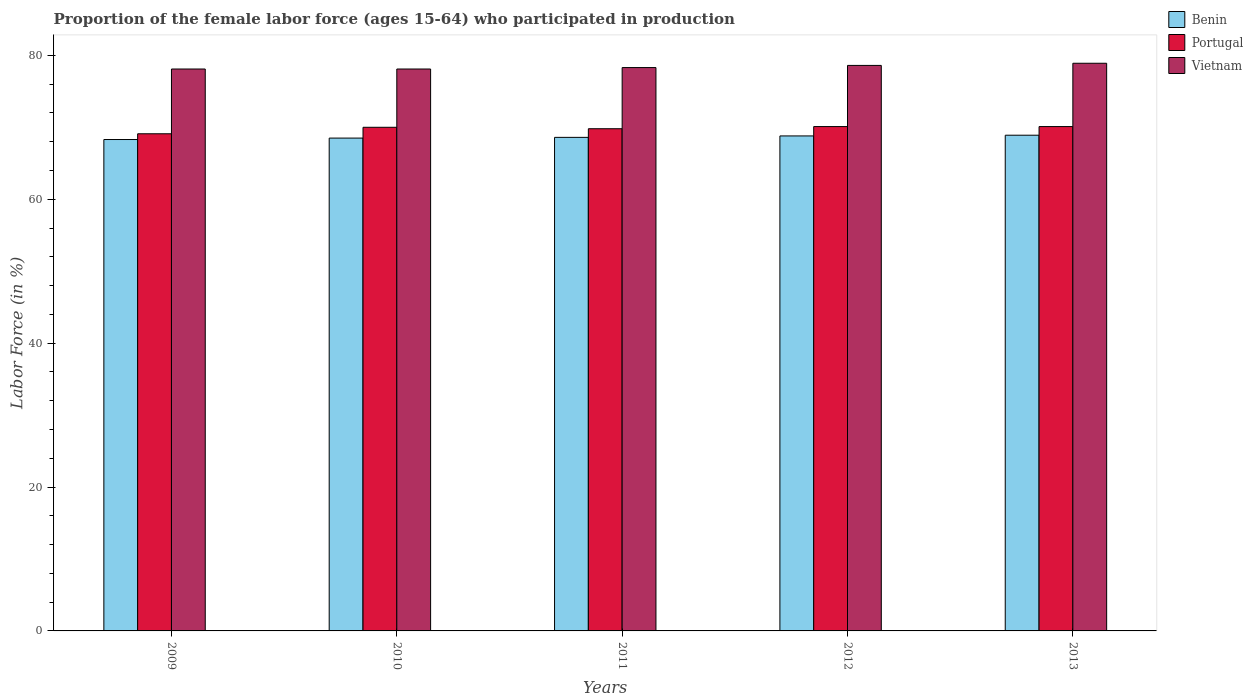Are the number of bars per tick equal to the number of legend labels?
Offer a terse response. Yes. Are the number of bars on each tick of the X-axis equal?
Keep it short and to the point. Yes. How many bars are there on the 5th tick from the left?
Offer a terse response. 3. What is the label of the 1st group of bars from the left?
Offer a very short reply. 2009. In how many cases, is the number of bars for a given year not equal to the number of legend labels?
Your response must be concise. 0. What is the proportion of the female labor force who participated in production in Benin in 2013?
Ensure brevity in your answer.  68.9. Across all years, what is the maximum proportion of the female labor force who participated in production in Vietnam?
Give a very brief answer. 78.9. Across all years, what is the minimum proportion of the female labor force who participated in production in Portugal?
Your answer should be very brief. 69.1. What is the total proportion of the female labor force who participated in production in Benin in the graph?
Your response must be concise. 343.1. What is the difference between the proportion of the female labor force who participated in production in Portugal in 2009 and that in 2013?
Your answer should be very brief. -1. What is the difference between the proportion of the female labor force who participated in production in Portugal in 2010 and the proportion of the female labor force who participated in production in Benin in 2009?
Your answer should be compact. 1.7. What is the average proportion of the female labor force who participated in production in Vietnam per year?
Your answer should be very brief. 78.4. In the year 2013, what is the difference between the proportion of the female labor force who participated in production in Portugal and proportion of the female labor force who participated in production in Benin?
Give a very brief answer. 1.2. What is the ratio of the proportion of the female labor force who participated in production in Benin in 2009 to that in 2012?
Offer a very short reply. 0.99. Is the proportion of the female labor force who participated in production in Portugal in 2010 less than that in 2013?
Make the answer very short. Yes. What is the difference between the highest and the lowest proportion of the female labor force who participated in production in Benin?
Your response must be concise. 0.6. In how many years, is the proportion of the female labor force who participated in production in Benin greater than the average proportion of the female labor force who participated in production in Benin taken over all years?
Keep it short and to the point. 2. What does the 2nd bar from the left in 2012 represents?
Offer a terse response. Portugal. What does the 1st bar from the right in 2010 represents?
Keep it short and to the point. Vietnam. Is it the case that in every year, the sum of the proportion of the female labor force who participated in production in Portugal and proportion of the female labor force who participated in production in Benin is greater than the proportion of the female labor force who participated in production in Vietnam?
Your answer should be very brief. Yes. How many bars are there?
Make the answer very short. 15. Are all the bars in the graph horizontal?
Offer a terse response. No. Does the graph contain grids?
Your answer should be very brief. No. Where does the legend appear in the graph?
Make the answer very short. Top right. What is the title of the graph?
Keep it short and to the point. Proportion of the female labor force (ages 15-64) who participated in production. What is the label or title of the X-axis?
Keep it short and to the point. Years. What is the Labor Force (in %) of Benin in 2009?
Your answer should be compact. 68.3. What is the Labor Force (in %) in Portugal in 2009?
Give a very brief answer. 69.1. What is the Labor Force (in %) in Vietnam in 2009?
Your response must be concise. 78.1. What is the Labor Force (in %) in Benin in 2010?
Give a very brief answer. 68.5. What is the Labor Force (in %) in Portugal in 2010?
Offer a very short reply. 70. What is the Labor Force (in %) in Vietnam in 2010?
Provide a short and direct response. 78.1. What is the Labor Force (in %) in Benin in 2011?
Keep it short and to the point. 68.6. What is the Labor Force (in %) of Portugal in 2011?
Provide a short and direct response. 69.8. What is the Labor Force (in %) in Vietnam in 2011?
Provide a short and direct response. 78.3. What is the Labor Force (in %) in Benin in 2012?
Provide a succinct answer. 68.8. What is the Labor Force (in %) in Portugal in 2012?
Make the answer very short. 70.1. What is the Labor Force (in %) in Vietnam in 2012?
Your answer should be compact. 78.6. What is the Labor Force (in %) of Benin in 2013?
Your response must be concise. 68.9. What is the Labor Force (in %) in Portugal in 2013?
Your response must be concise. 70.1. What is the Labor Force (in %) in Vietnam in 2013?
Ensure brevity in your answer.  78.9. Across all years, what is the maximum Labor Force (in %) in Benin?
Make the answer very short. 68.9. Across all years, what is the maximum Labor Force (in %) in Portugal?
Your answer should be very brief. 70.1. Across all years, what is the maximum Labor Force (in %) of Vietnam?
Provide a succinct answer. 78.9. Across all years, what is the minimum Labor Force (in %) in Benin?
Give a very brief answer. 68.3. Across all years, what is the minimum Labor Force (in %) of Portugal?
Offer a very short reply. 69.1. Across all years, what is the minimum Labor Force (in %) in Vietnam?
Offer a very short reply. 78.1. What is the total Labor Force (in %) in Benin in the graph?
Give a very brief answer. 343.1. What is the total Labor Force (in %) in Portugal in the graph?
Your answer should be very brief. 349.1. What is the total Labor Force (in %) of Vietnam in the graph?
Provide a short and direct response. 392. What is the difference between the Labor Force (in %) of Portugal in 2009 and that in 2010?
Keep it short and to the point. -0.9. What is the difference between the Labor Force (in %) in Portugal in 2009 and that in 2011?
Give a very brief answer. -0.7. What is the difference between the Labor Force (in %) in Vietnam in 2009 and that in 2011?
Your answer should be compact. -0.2. What is the difference between the Labor Force (in %) in Portugal in 2009 and that in 2013?
Your answer should be compact. -1. What is the difference between the Labor Force (in %) in Benin in 2010 and that in 2011?
Provide a succinct answer. -0.1. What is the difference between the Labor Force (in %) in Portugal in 2010 and that in 2011?
Make the answer very short. 0.2. What is the difference between the Labor Force (in %) in Vietnam in 2010 and that in 2011?
Make the answer very short. -0.2. What is the difference between the Labor Force (in %) in Benin in 2010 and that in 2013?
Provide a succinct answer. -0.4. What is the difference between the Labor Force (in %) in Portugal in 2010 and that in 2013?
Your answer should be compact. -0.1. What is the difference between the Labor Force (in %) in Benin in 2011 and that in 2012?
Make the answer very short. -0.2. What is the difference between the Labor Force (in %) of Portugal in 2011 and that in 2013?
Make the answer very short. -0.3. What is the difference between the Labor Force (in %) of Portugal in 2012 and that in 2013?
Give a very brief answer. 0. What is the difference between the Labor Force (in %) in Vietnam in 2012 and that in 2013?
Your answer should be compact. -0.3. What is the difference between the Labor Force (in %) in Benin in 2009 and the Labor Force (in %) in Portugal in 2010?
Offer a very short reply. -1.7. What is the difference between the Labor Force (in %) of Benin in 2009 and the Labor Force (in %) of Vietnam in 2010?
Your response must be concise. -9.8. What is the difference between the Labor Force (in %) in Benin in 2009 and the Labor Force (in %) in Vietnam in 2011?
Your response must be concise. -10. What is the difference between the Labor Force (in %) of Benin in 2009 and the Labor Force (in %) of Portugal in 2012?
Make the answer very short. -1.8. What is the difference between the Labor Force (in %) in Portugal in 2009 and the Labor Force (in %) in Vietnam in 2012?
Offer a very short reply. -9.5. What is the difference between the Labor Force (in %) in Benin in 2009 and the Labor Force (in %) in Vietnam in 2013?
Your answer should be very brief. -10.6. What is the difference between the Labor Force (in %) of Portugal in 2009 and the Labor Force (in %) of Vietnam in 2013?
Give a very brief answer. -9.8. What is the difference between the Labor Force (in %) in Benin in 2010 and the Labor Force (in %) in Portugal in 2011?
Offer a very short reply. -1.3. What is the difference between the Labor Force (in %) in Benin in 2010 and the Labor Force (in %) in Vietnam in 2011?
Keep it short and to the point. -9.8. What is the difference between the Labor Force (in %) in Benin in 2010 and the Labor Force (in %) in Portugal in 2012?
Your answer should be compact. -1.6. What is the difference between the Labor Force (in %) of Portugal in 2010 and the Labor Force (in %) of Vietnam in 2012?
Offer a terse response. -8.6. What is the difference between the Labor Force (in %) of Portugal in 2010 and the Labor Force (in %) of Vietnam in 2013?
Offer a very short reply. -8.9. What is the difference between the Labor Force (in %) in Benin in 2011 and the Labor Force (in %) in Portugal in 2012?
Provide a succinct answer. -1.5. What is the difference between the Labor Force (in %) of Benin in 2012 and the Labor Force (in %) of Vietnam in 2013?
Offer a very short reply. -10.1. What is the average Labor Force (in %) of Benin per year?
Your answer should be very brief. 68.62. What is the average Labor Force (in %) in Portugal per year?
Your answer should be compact. 69.82. What is the average Labor Force (in %) in Vietnam per year?
Offer a terse response. 78.4. In the year 2009, what is the difference between the Labor Force (in %) of Benin and Labor Force (in %) of Vietnam?
Keep it short and to the point. -9.8. In the year 2010, what is the difference between the Labor Force (in %) of Benin and Labor Force (in %) of Vietnam?
Your answer should be very brief. -9.6. In the year 2010, what is the difference between the Labor Force (in %) of Portugal and Labor Force (in %) of Vietnam?
Your answer should be compact. -8.1. In the year 2011, what is the difference between the Labor Force (in %) of Benin and Labor Force (in %) of Portugal?
Offer a terse response. -1.2. In the year 2011, what is the difference between the Labor Force (in %) in Benin and Labor Force (in %) in Vietnam?
Ensure brevity in your answer.  -9.7. In the year 2011, what is the difference between the Labor Force (in %) in Portugal and Labor Force (in %) in Vietnam?
Your answer should be very brief. -8.5. In the year 2012, what is the difference between the Labor Force (in %) in Portugal and Labor Force (in %) in Vietnam?
Offer a very short reply. -8.5. In the year 2013, what is the difference between the Labor Force (in %) of Benin and Labor Force (in %) of Portugal?
Your answer should be very brief. -1.2. What is the ratio of the Labor Force (in %) of Portugal in 2009 to that in 2010?
Ensure brevity in your answer.  0.99. What is the ratio of the Labor Force (in %) of Portugal in 2009 to that in 2011?
Provide a short and direct response. 0.99. What is the ratio of the Labor Force (in %) in Vietnam in 2009 to that in 2011?
Keep it short and to the point. 1. What is the ratio of the Labor Force (in %) of Benin in 2009 to that in 2012?
Give a very brief answer. 0.99. What is the ratio of the Labor Force (in %) of Portugal in 2009 to that in 2012?
Give a very brief answer. 0.99. What is the ratio of the Labor Force (in %) of Vietnam in 2009 to that in 2012?
Keep it short and to the point. 0.99. What is the ratio of the Labor Force (in %) of Benin in 2009 to that in 2013?
Offer a very short reply. 0.99. What is the ratio of the Labor Force (in %) of Portugal in 2009 to that in 2013?
Provide a succinct answer. 0.99. What is the ratio of the Labor Force (in %) of Benin in 2010 to that in 2011?
Your answer should be very brief. 1. What is the ratio of the Labor Force (in %) in Portugal in 2010 to that in 2011?
Make the answer very short. 1. What is the ratio of the Labor Force (in %) in Vietnam in 2010 to that in 2012?
Provide a short and direct response. 0.99. What is the ratio of the Labor Force (in %) of Portugal in 2010 to that in 2013?
Keep it short and to the point. 1. What is the ratio of the Labor Force (in %) in Vietnam in 2010 to that in 2013?
Your response must be concise. 0.99. What is the ratio of the Labor Force (in %) of Benin in 2011 to that in 2012?
Give a very brief answer. 1. What is the ratio of the Labor Force (in %) in Portugal in 2011 to that in 2013?
Offer a terse response. 1. What is the ratio of the Labor Force (in %) in Benin in 2012 to that in 2013?
Your answer should be compact. 1. What is the ratio of the Labor Force (in %) in Vietnam in 2012 to that in 2013?
Your response must be concise. 1. What is the difference between the highest and the second highest Labor Force (in %) of Benin?
Give a very brief answer. 0.1. What is the difference between the highest and the second highest Labor Force (in %) in Vietnam?
Ensure brevity in your answer.  0.3. What is the difference between the highest and the lowest Labor Force (in %) in Portugal?
Provide a succinct answer. 1. 